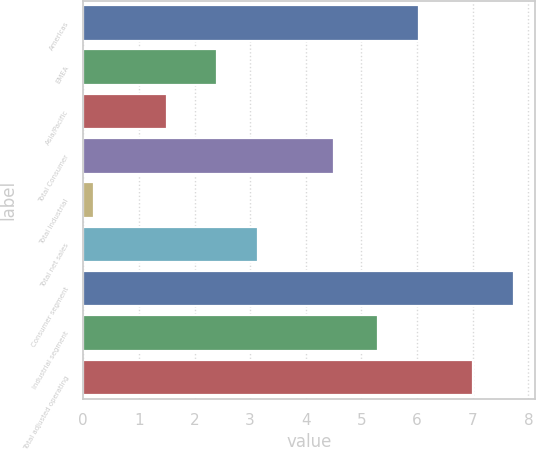Convert chart. <chart><loc_0><loc_0><loc_500><loc_500><bar_chart><fcel>Americas<fcel>EMEA<fcel>Asia/Pacific<fcel>Total Consumer<fcel>Total Industrial<fcel>Total net sales<fcel>Consumer segment<fcel>Industrial segment<fcel>Total adjusted operating<nl><fcel>6.04<fcel>2.4<fcel>1.5<fcel>4.5<fcel>0.2<fcel>3.14<fcel>7.74<fcel>5.3<fcel>7<nl></chart> 